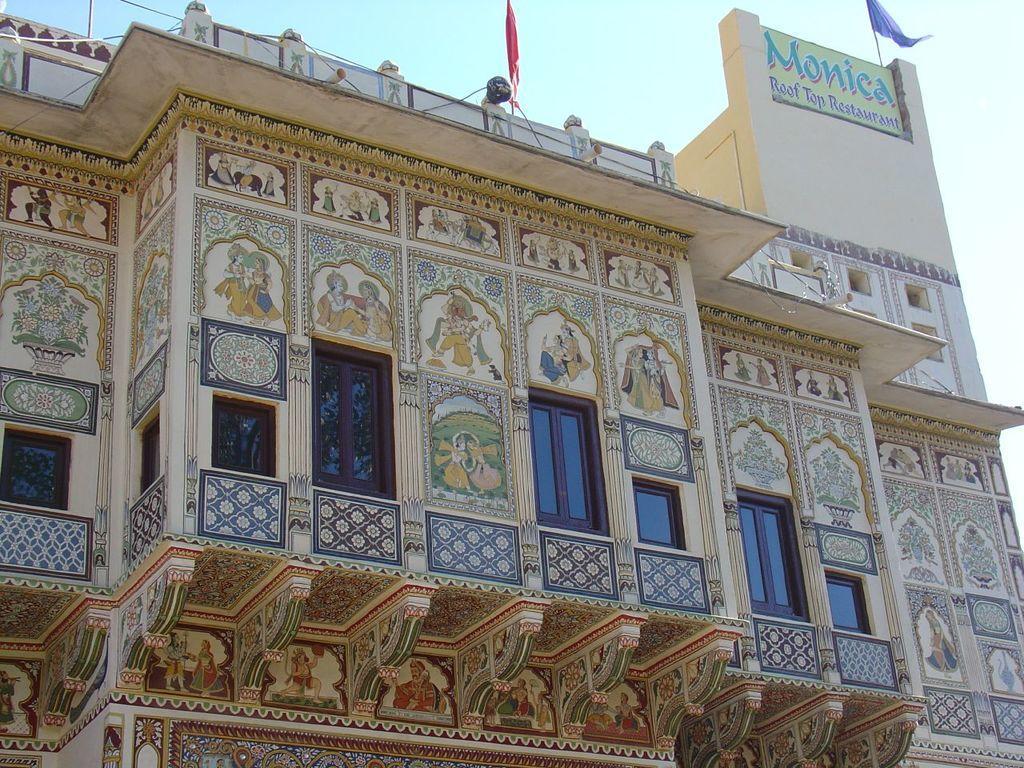Please provide a concise description of this image. In this image, we can see a building and there are some windows on the building, we can see a hoarding on the building, at the top we can see the sky. 